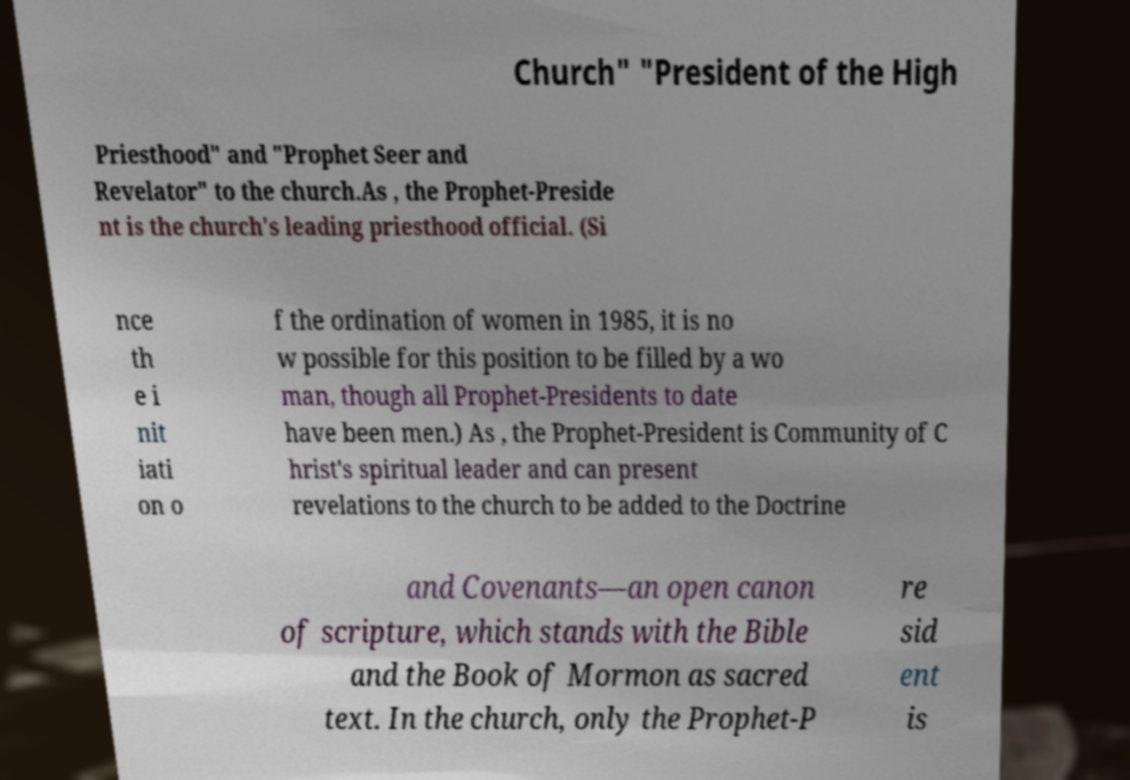What messages or text are displayed in this image? I need them in a readable, typed format. Church" "President of the High Priesthood" and "Prophet Seer and Revelator" to the church.As , the Prophet-Preside nt is the church's leading priesthood official. (Si nce th e i nit iati on o f the ordination of women in 1985, it is no w possible for this position to be filled by a wo man, though all Prophet-Presidents to date have been men.) As , the Prophet-President is Community of C hrist's spiritual leader and can present revelations to the church to be added to the Doctrine and Covenants—an open canon of scripture, which stands with the Bible and the Book of Mormon as sacred text. In the church, only the Prophet-P re sid ent is 